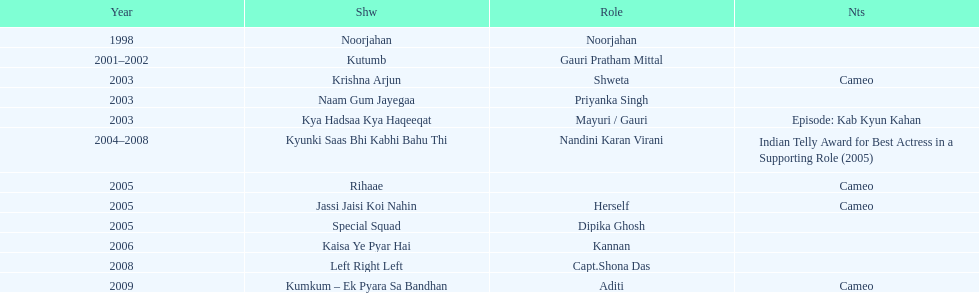How many total television shows has gauri starred in? 12. 